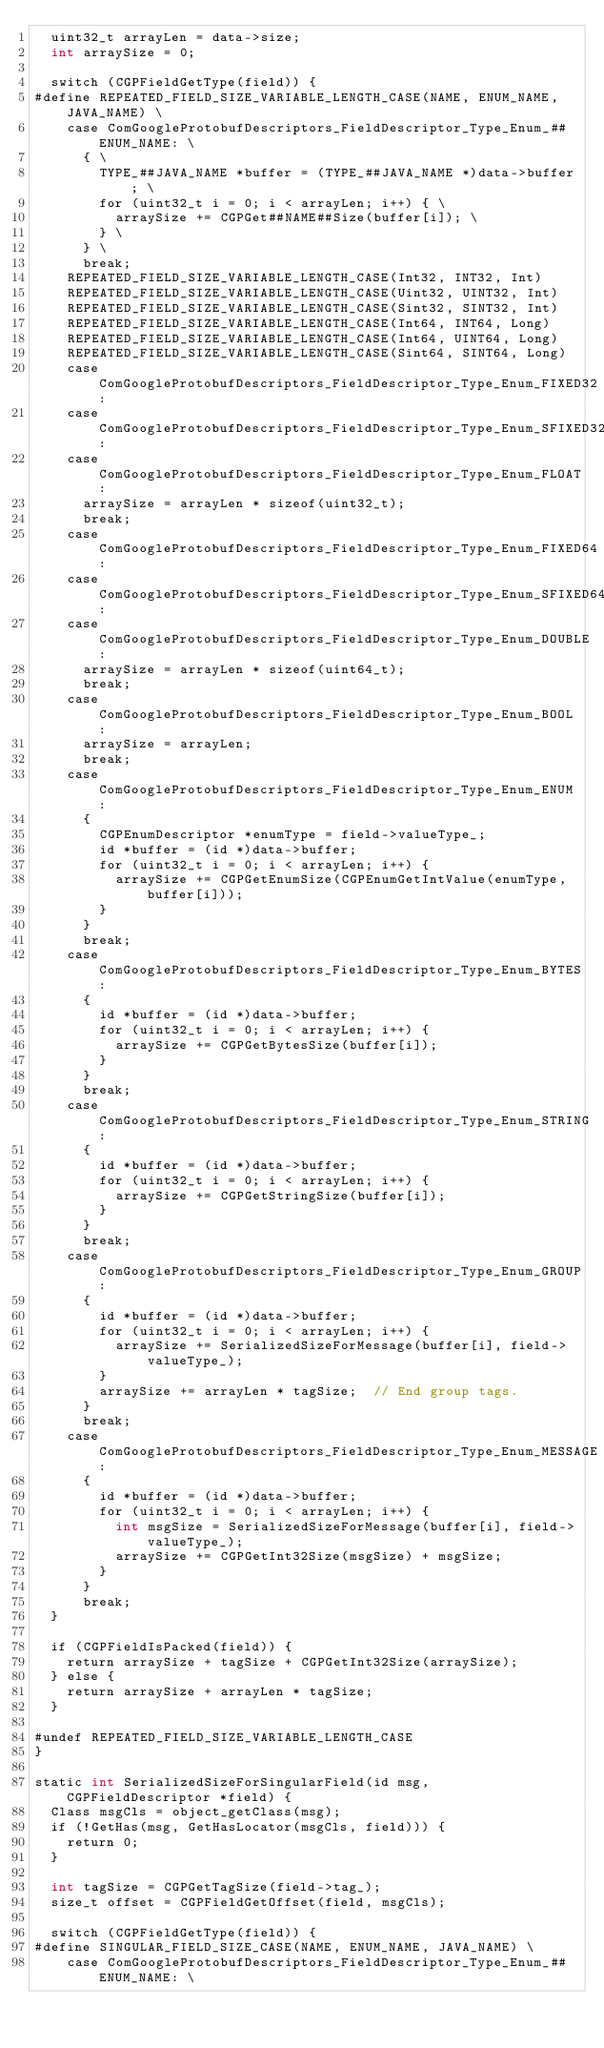<code> <loc_0><loc_0><loc_500><loc_500><_ObjectiveC_>  uint32_t arrayLen = data->size;
  int arraySize = 0;

  switch (CGPFieldGetType(field)) {
#define REPEATED_FIELD_SIZE_VARIABLE_LENGTH_CASE(NAME, ENUM_NAME, JAVA_NAME) \
    case ComGoogleProtobufDescriptors_FieldDescriptor_Type_Enum_##ENUM_NAME: \
      { \
        TYPE_##JAVA_NAME *buffer = (TYPE_##JAVA_NAME *)data->buffer; \
        for (uint32_t i = 0; i < arrayLen; i++) { \
          arraySize += CGPGet##NAME##Size(buffer[i]); \
        } \
      } \
      break;
    REPEATED_FIELD_SIZE_VARIABLE_LENGTH_CASE(Int32, INT32, Int)
    REPEATED_FIELD_SIZE_VARIABLE_LENGTH_CASE(Uint32, UINT32, Int)
    REPEATED_FIELD_SIZE_VARIABLE_LENGTH_CASE(Sint32, SINT32, Int)
    REPEATED_FIELD_SIZE_VARIABLE_LENGTH_CASE(Int64, INT64, Long)
    REPEATED_FIELD_SIZE_VARIABLE_LENGTH_CASE(Int64, UINT64, Long)
    REPEATED_FIELD_SIZE_VARIABLE_LENGTH_CASE(Sint64, SINT64, Long)
    case ComGoogleProtobufDescriptors_FieldDescriptor_Type_Enum_FIXED32:
    case ComGoogleProtobufDescriptors_FieldDescriptor_Type_Enum_SFIXED32:
    case ComGoogleProtobufDescriptors_FieldDescriptor_Type_Enum_FLOAT:
      arraySize = arrayLen * sizeof(uint32_t);
      break;
    case ComGoogleProtobufDescriptors_FieldDescriptor_Type_Enum_FIXED64:
    case ComGoogleProtobufDescriptors_FieldDescriptor_Type_Enum_SFIXED64:
    case ComGoogleProtobufDescriptors_FieldDescriptor_Type_Enum_DOUBLE:
      arraySize = arrayLen * sizeof(uint64_t);
      break;
    case ComGoogleProtobufDescriptors_FieldDescriptor_Type_Enum_BOOL:
      arraySize = arrayLen;
      break;
    case ComGoogleProtobufDescriptors_FieldDescriptor_Type_Enum_ENUM:
      {
        CGPEnumDescriptor *enumType = field->valueType_;
        id *buffer = (id *)data->buffer;
        for (uint32_t i = 0; i < arrayLen; i++) {
          arraySize += CGPGetEnumSize(CGPEnumGetIntValue(enumType, buffer[i]));
        }
      }
      break;
    case ComGoogleProtobufDescriptors_FieldDescriptor_Type_Enum_BYTES:
      {
        id *buffer = (id *)data->buffer;
        for (uint32_t i = 0; i < arrayLen; i++) {
          arraySize += CGPGetBytesSize(buffer[i]);
        }
      }
      break;
    case ComGoogleProtobufDescriptors_FieldDescriptor_Type_Enum_STRING:
      {
        id *buffer = (id *)data->buffer;
        for (uint32_t i = 0; i < arrayLen; i++) {
          arraySize += CGPGetStringSize(buffer[i]);
        }
      }
      break;
    case ComGoogleProtobufDescriptors_FieldDescriptor_Type_Enum_GROUP:
      {
        id *buffer = (id *)data->buffer;
        for (uint32_t i = 0; i < arrayLen; i++) {
          arraySize += SerializedSizeForMessage(buffer[i], field->valueType_);
        }
        arraySize += arrayLen * tagSize;  // End group tags.
      }
      break;
    case ComGoogleProtobufDescriptors_FieldDescriptor_Type_Enum_MESSAGE:
      {
        id *buffer = (id *)data->buffer;
        for (uint32_t i = 0; i < arrayLen; i++) {
          int msgSize = SerializedSizeForMessage(buffer[i], field->valueType_);
          arraySize += CGPGetInt32Size(msgSize) + msgSize;
        }
      }
      break;
  }

  if (CGPFieldIsPacked(field)) {
    return arraySize + tagSize + CGPGetInt32Size(arraySize);
  } else {
    return arraySize + arrayLen * tagSize;
  }

#undef REPEATED_FIELD_SIZE_VARIABLE_LENGTH_CASE
}

static int SerializedSizeForSingularField(id msg, CGPFieldDescriptor *field) {
  Class msgCls = object_getClass(msg);
  if (!GetHas(msg, GetHasLocator(msgCls, field))) {
    return 0;
  }

  int tagSize = CGPGetTagSize(field->tag_);
  size_t offset = CGPFieldGetOffset(field, msgCls);

  switch (CGPFieldGetType(field)) {
#define SINGULAR_FIELD_SIZE_CASE(NAME, ENUM_NAME, JAVA_NAME) \
    case ComGoogleProtobufDescriptors_FieldDescriptor_Type_Enum_##ENUM_NAME: \</code> 